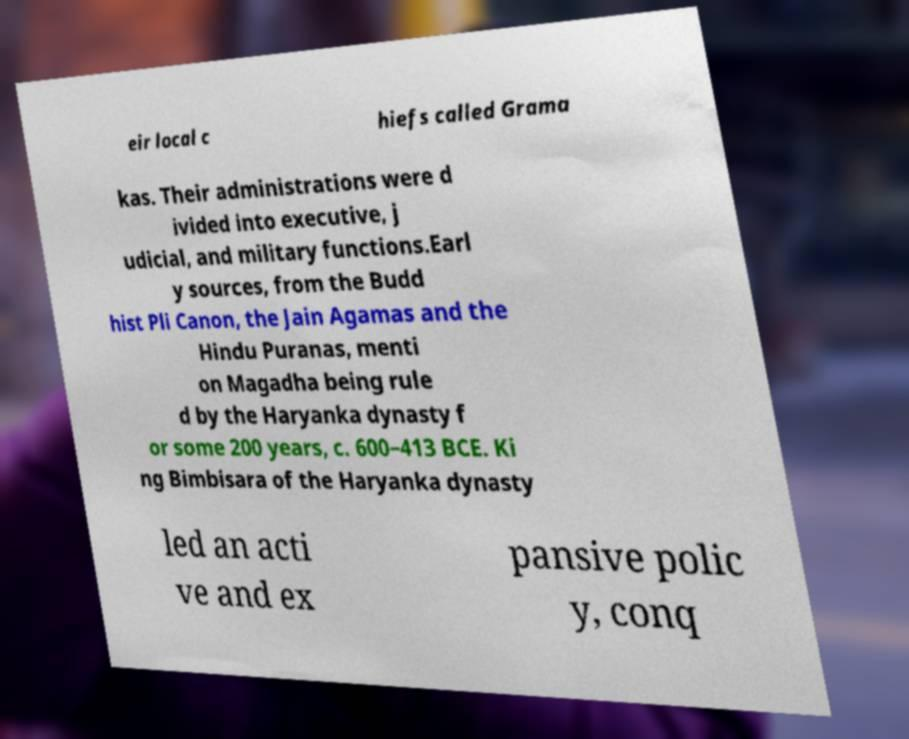Could you assist in decoding the text presented in this image and type it out clearly? eir local c hiefs called Grama kas. Their administrations were d ivided into executive, j udicial, and military functions.Earl y sources, from the Budd hist Pli Canon, the Jain Agamas and the Hindu Puranas, menti on Magadha being rule d by the Haryanka dynasty f or some 200 years, c. 600–413 BCE. Ki ng Bimbisara of the Haryanka dynasty led an acti ve and ex pansive polic y, conq 